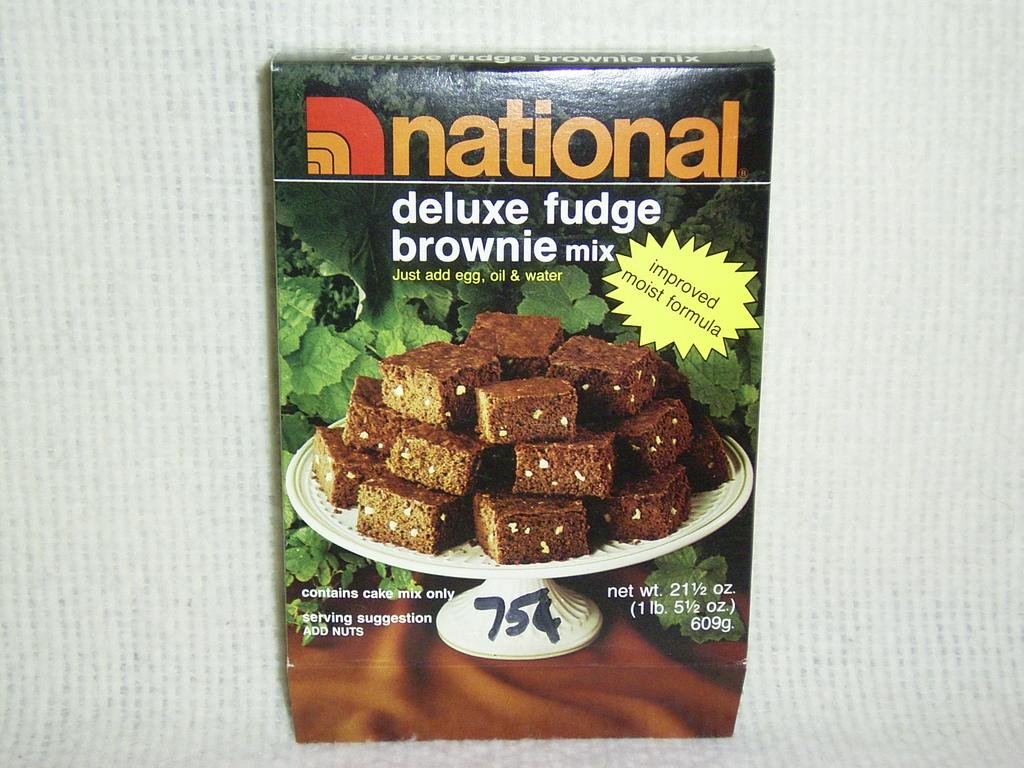What is the main object in the image? There is a brownie mix box in the image. What is the color of the surface on which the brownie mix box is placed? The brownie mix box is placed on a white surface. What type of cave can be seen in the background of the image? There is no cave present in the image; it only features a brownie mix box placed on a white surface. 